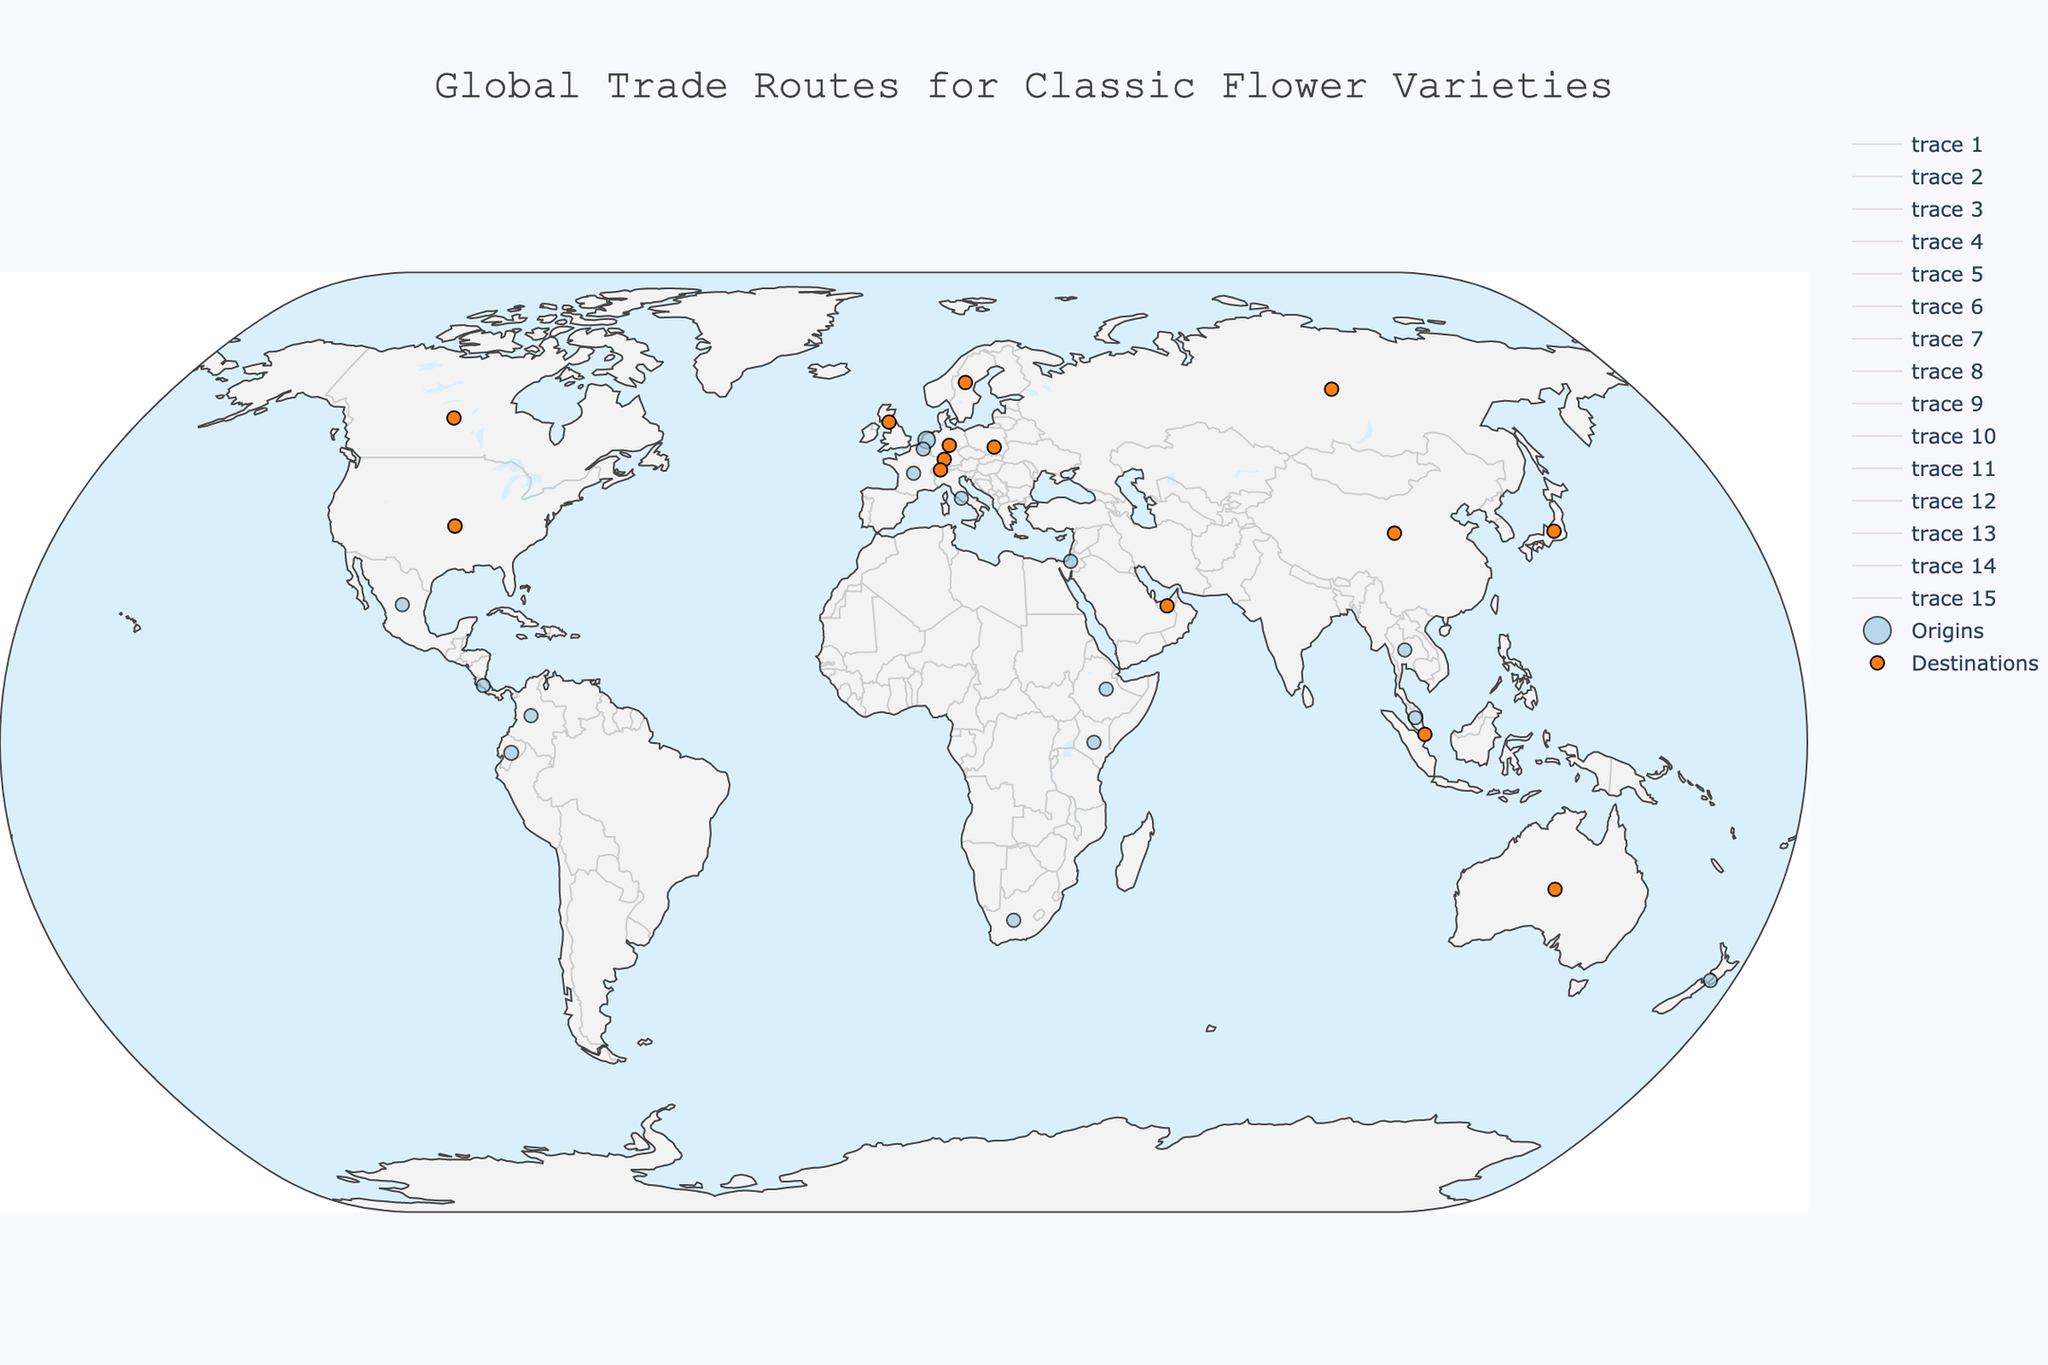How many origin points are marked on the map? Count the unique origin points marked by the blue markers on the map.
Answer: 15 Which origin exports the most flower varieties? Count the number of different flower types each origin exports. The origin with the maximum count is the answer.
Answer: Ethiopia (3 types) What is the total trade volume (in tons) of roses exported globally? Identify and sum up the trade volumes of flowers categorized as "Roses". These include exports from Ecuador, Kenya, and Ethiopia. 1800 + 1600 + 1400 = 4800 tons.
Answer: 4800 tons Which destination receives flowers from the maximum number of unique origins? Count how many different origins export to each destination. The destination with the maximum number is the answer. Map the destinations of "United States", "Russia", "Japan", etc. Count the origins.
Answer: United States (2 origins) How many destination points are marked on the map? Count the unique destination points marked by the orange markers on the map.
Answer: 14 Which origin has the highest single trade volume destination, and what is the volume? Identify the highest trade volume (tons) for each origin and determine the origin with the highest value. The highest individual trade volume between origins and destinations is from the Netherlands (2500 tons).
Answer: Netherlands, 2500 tons Compare the total flower varieties traded from African countries versus South American countries. Which group has a higher trade volume? Identify origin countries from Africa (Kenya, Ethiopia, South Africa) and South America (Ecuador, Colombia). Sum the trade volumes for each group and compare. Africa: 1600 + 1400 + 400. South America: 1800 + 1200. Africa = 3400 tons, South America = 3000 tons.
Answer: African countries (3400 tons) Which origin country exports the smallest volume of flowers, and what type of flower is it? Identify the origin with the smallest trade volume in the "Flower Type" column. It is Malaysia with 250 tons of Jasmine.
Answer: Malaysia, Jasmine, 250 tons How does the trade volume of Tulips from the Netherlands compare to the trade volume of Proteas from South Africa? Compare the trade volume value for Tulips (2500 tons) and Proteas (400 tons). Tulips have a higher trade volume.
Answer: Tulips are higher What is the average trade volume (in tons) per flower type? Sum up the total trade volume and divide by the number of flower types. Total trade volume is 14000 tons over 12 flower types: 2500 + 1800 + 1200 + 1600 + 900 + 700 + 600 + 1400 + 1000 + 500 + 300 + 400. Average volume is 14000/12 = 1166.67 tons.
Answer: 1166.67 tons 